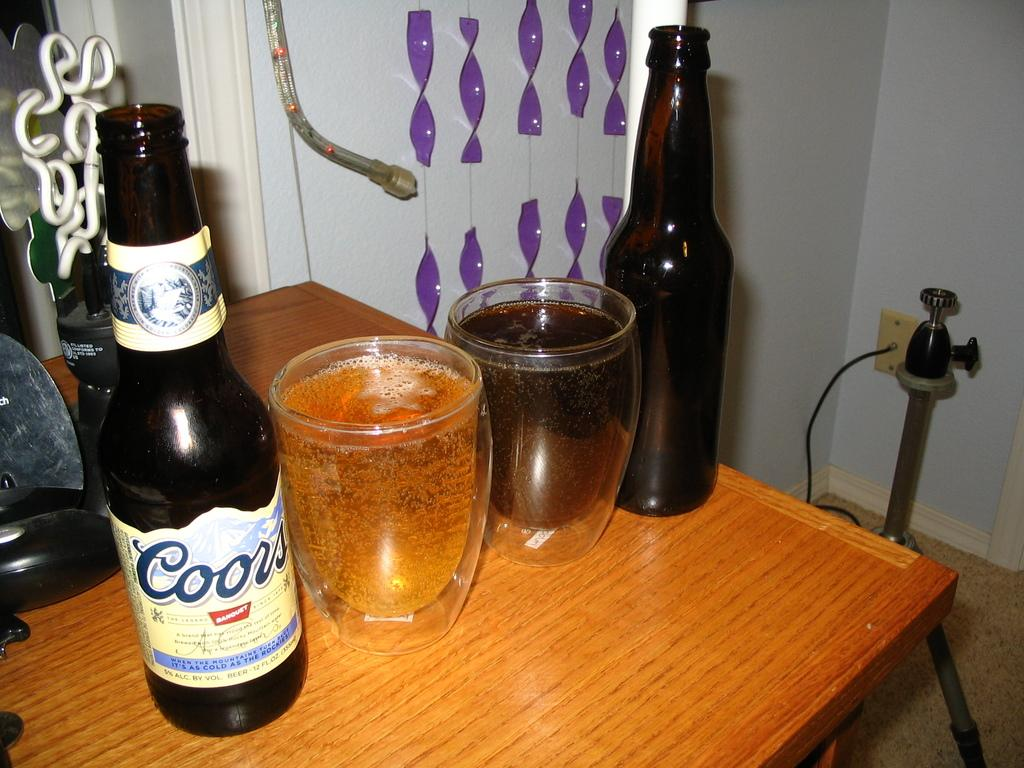<image>
Write a terse but informative summary of the picture. A bottle of Coors on a table next to two glasses of beer and another bottle. 